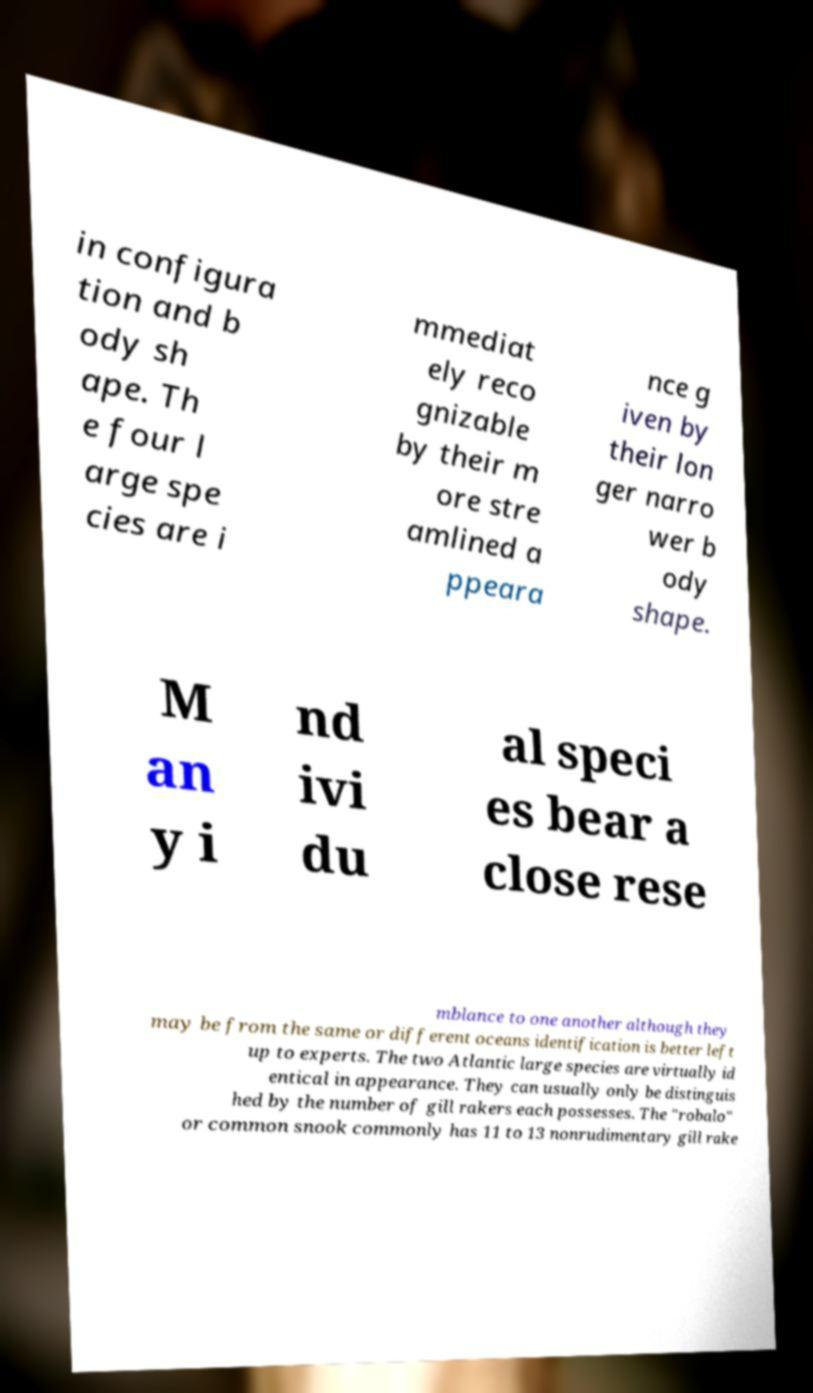I need the written content from this picture converted into text. Can you do that? in configura tion and b ody sh ape. Th e four l arge spe cies are i mmediat ely reco gnizable by their m ore stre amlined a ppeara nce g iven by their lon ger narro wer b ody shape. M an y i nd ivi du al speci es bear a close rese mblance to one another although they may be from the same or different oceans identification is better left up to experts. The two Atlantic large species are virtually id entical in appearance. They can usually only be distinguis hed by the number of gill rakers each possesses. The "robalo" or common snook commonly has 11 to 13 nonrudimentary gill rake 